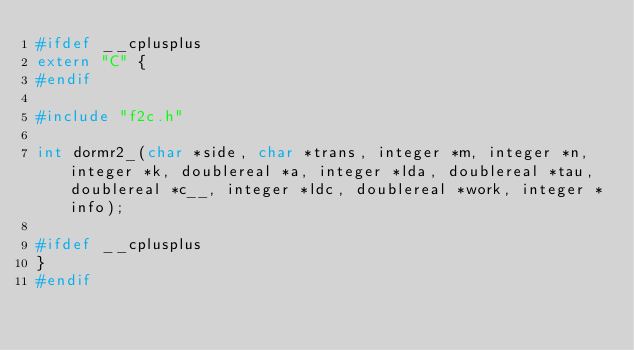<code> <loc_0><loc_0><loc_500><loc_500><_C_>#ifdef __cplusplus
extern "C" { 
#endif  

#include "f2c.h" 

int dormr2_(char *side, char *trans, integer *m, integer *n, integer *k, doublereal *a, integer *lda, doublereal *tau, doublereal *c__, integer *ldc, doublereal *work, integer *info);

#ifdef __cplusplus
}
#endif</code> 